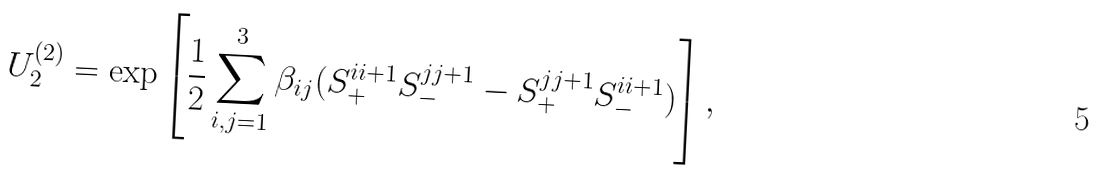Convert formula to latex. <formula><loc_0><loc_0><loc_500><loc_500>U _ { 2 } ^ { ( 2 ) } = \exp \left [ \frac { 1 } { 2 } \sum _ { i , j = 1 } ^ { 3 } \beta _ { i j } ( S _ { + } ^ { i i + 1 } S _ { - } ^ { j j + 1 } - S _ { + } ^ { j j + 1 } S _ { - } ^ { i i + 1 } ) \right ] ,</formula> 